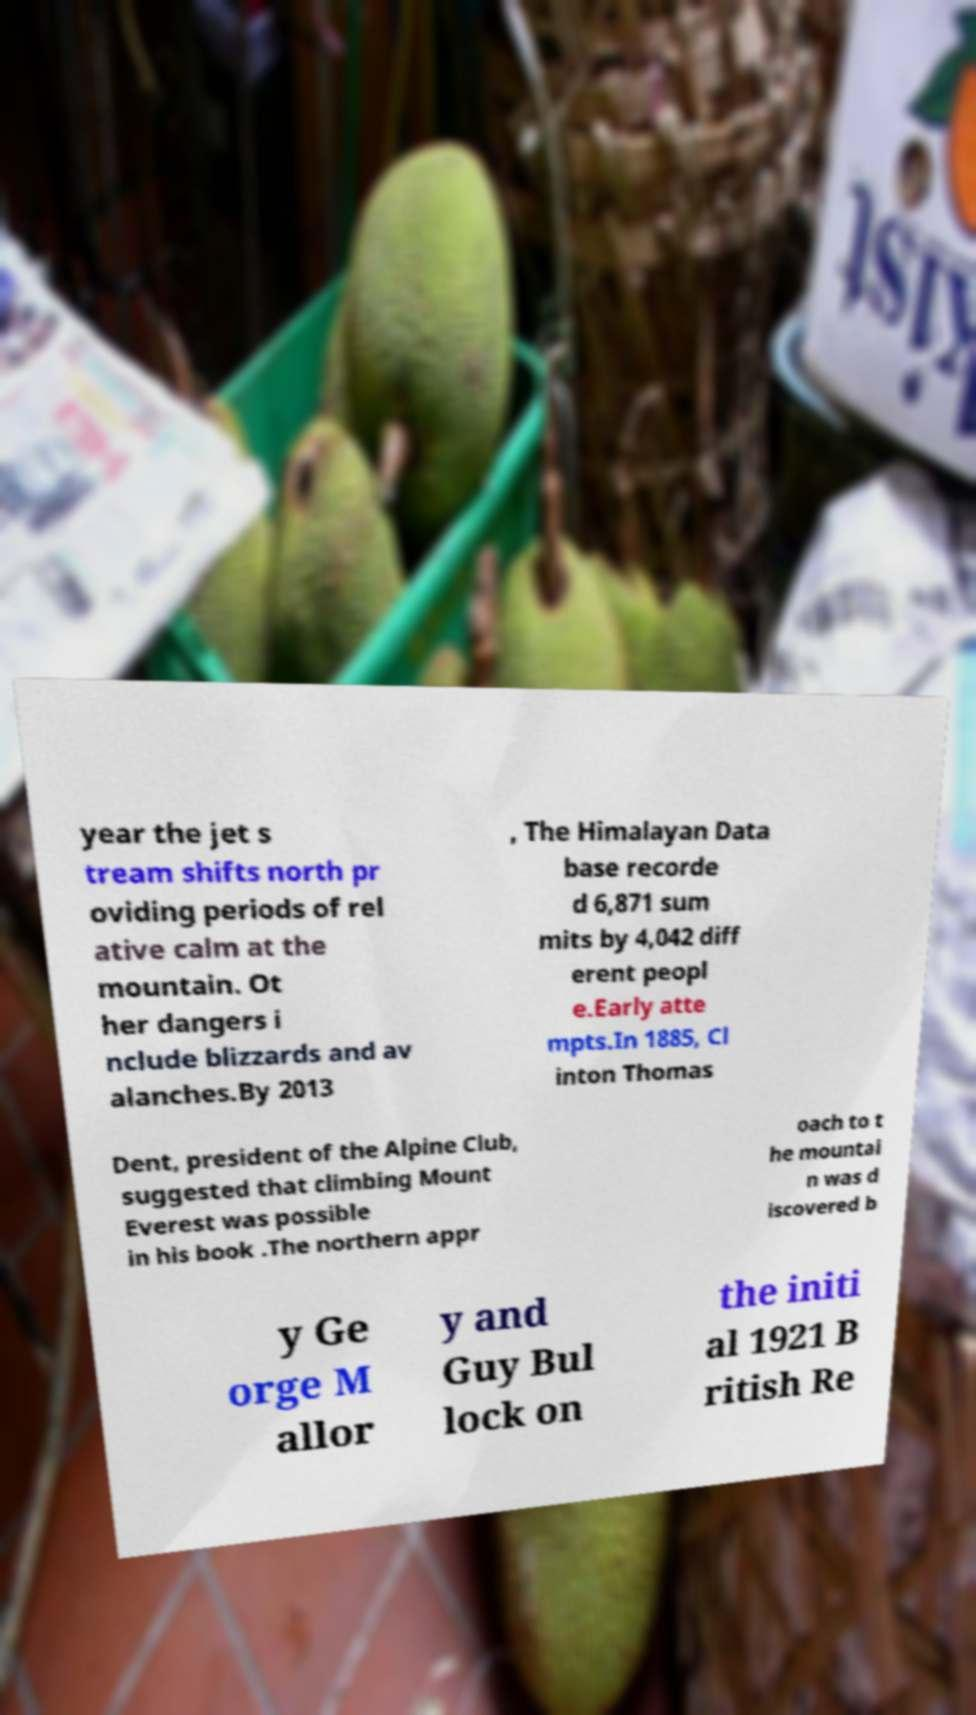For documentation purposes, I need the text within this image transcribed. Could you provide that? year the jet s tream shifts north pr oviding periods of rel ative calm at the mountain. Ot her dangers i nclude blizzards and av alanches.By 2013 , The Himalayan Data base recorde d 6,871 sum mits by 4,042 diff erent peopl e.Early atte mpts.In 1885, Cl inton Thomas Dent, president of the Alpine Club, suggested that climbing Mount Everest was possible in his book .The northern appr oach to t he mountai n was d iscovered b y Ge orge M allor y and Guy Bul lock on the initi al 1921 B ritish Re 